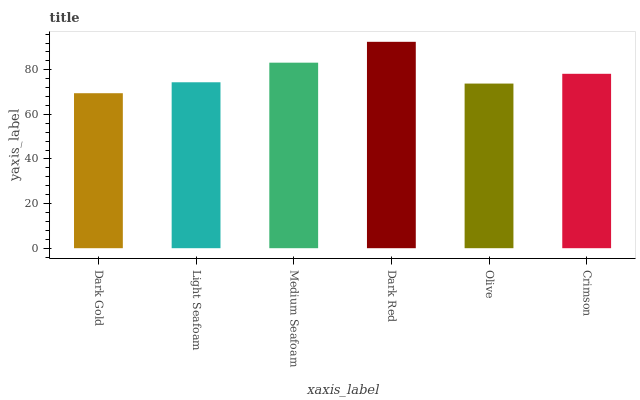Is Light Seafoam the minimum?
Answer yes or no. No. Is Light Seafoam the maximum?
Answer yes or no. No. Is Light Seafoam greater than Dark Gold?
Answer yes or no. Yes. Is Dark Gold less than Light Seafoam?
Answer yes or no. Yes. Is Dark Gold greater than Light Seafoam?
Answer yes or no. No. Is Light Seafoam less than Dark Gold?
Answer yes or no. No. Is Crimson the high median?
Answer yes or no. Yes. Is Light Seafoam the low median?
Answer yes or no. Yes. Is Light Seafoam the high median?
Answer yes or no. No. Is Dark Red the low median?
Answer yes or no. No. 